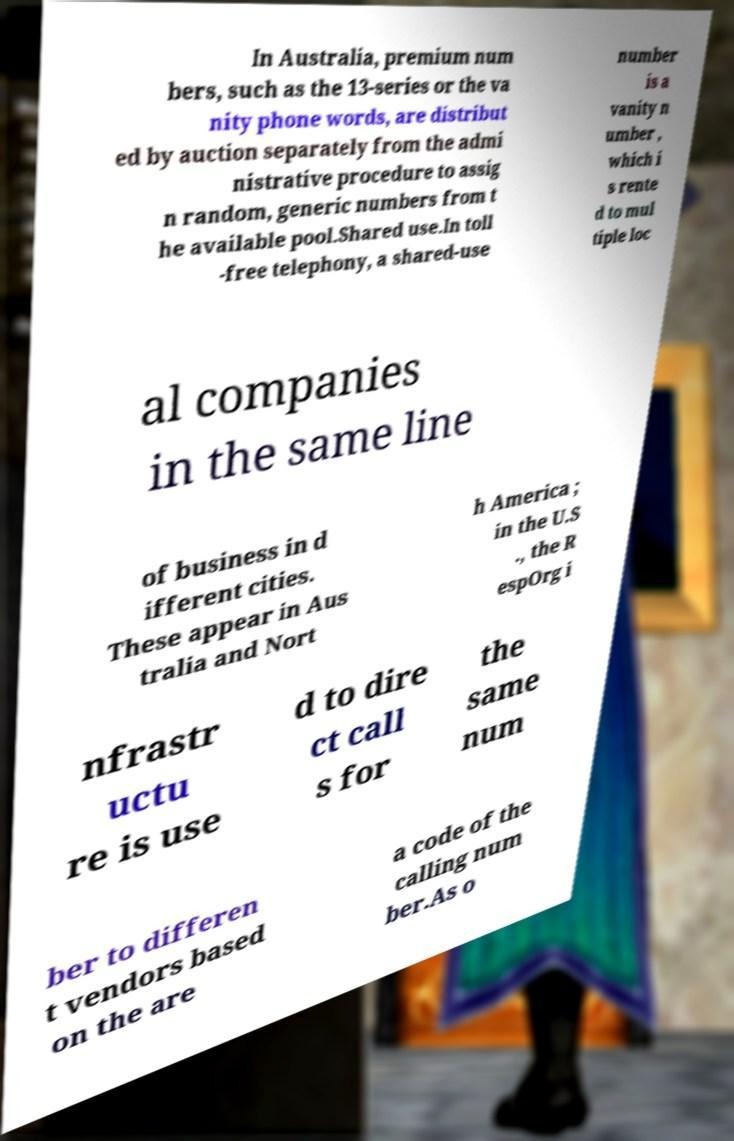Could you extract and type out the text from this image? In Australia, premium num bers, such as the 13-series or the va nity phone words, are distribut ed by auction separately from the admi nistrative procedure to assig n random, generic numbers from t he available pool.Shared use.In toll -free telephony, a shared-use number is a vanity n umber , which i s rente d to mul tiple loc al companies in the same line of business in d ifferent cities. These appear in Aus tralia and Nort h America ; in the U.S ., the R espOrg i nfrastr uctu re is use d to dire ct call s for the same num ber to differen t vendors based on the are a code of the calling num ber.As o 